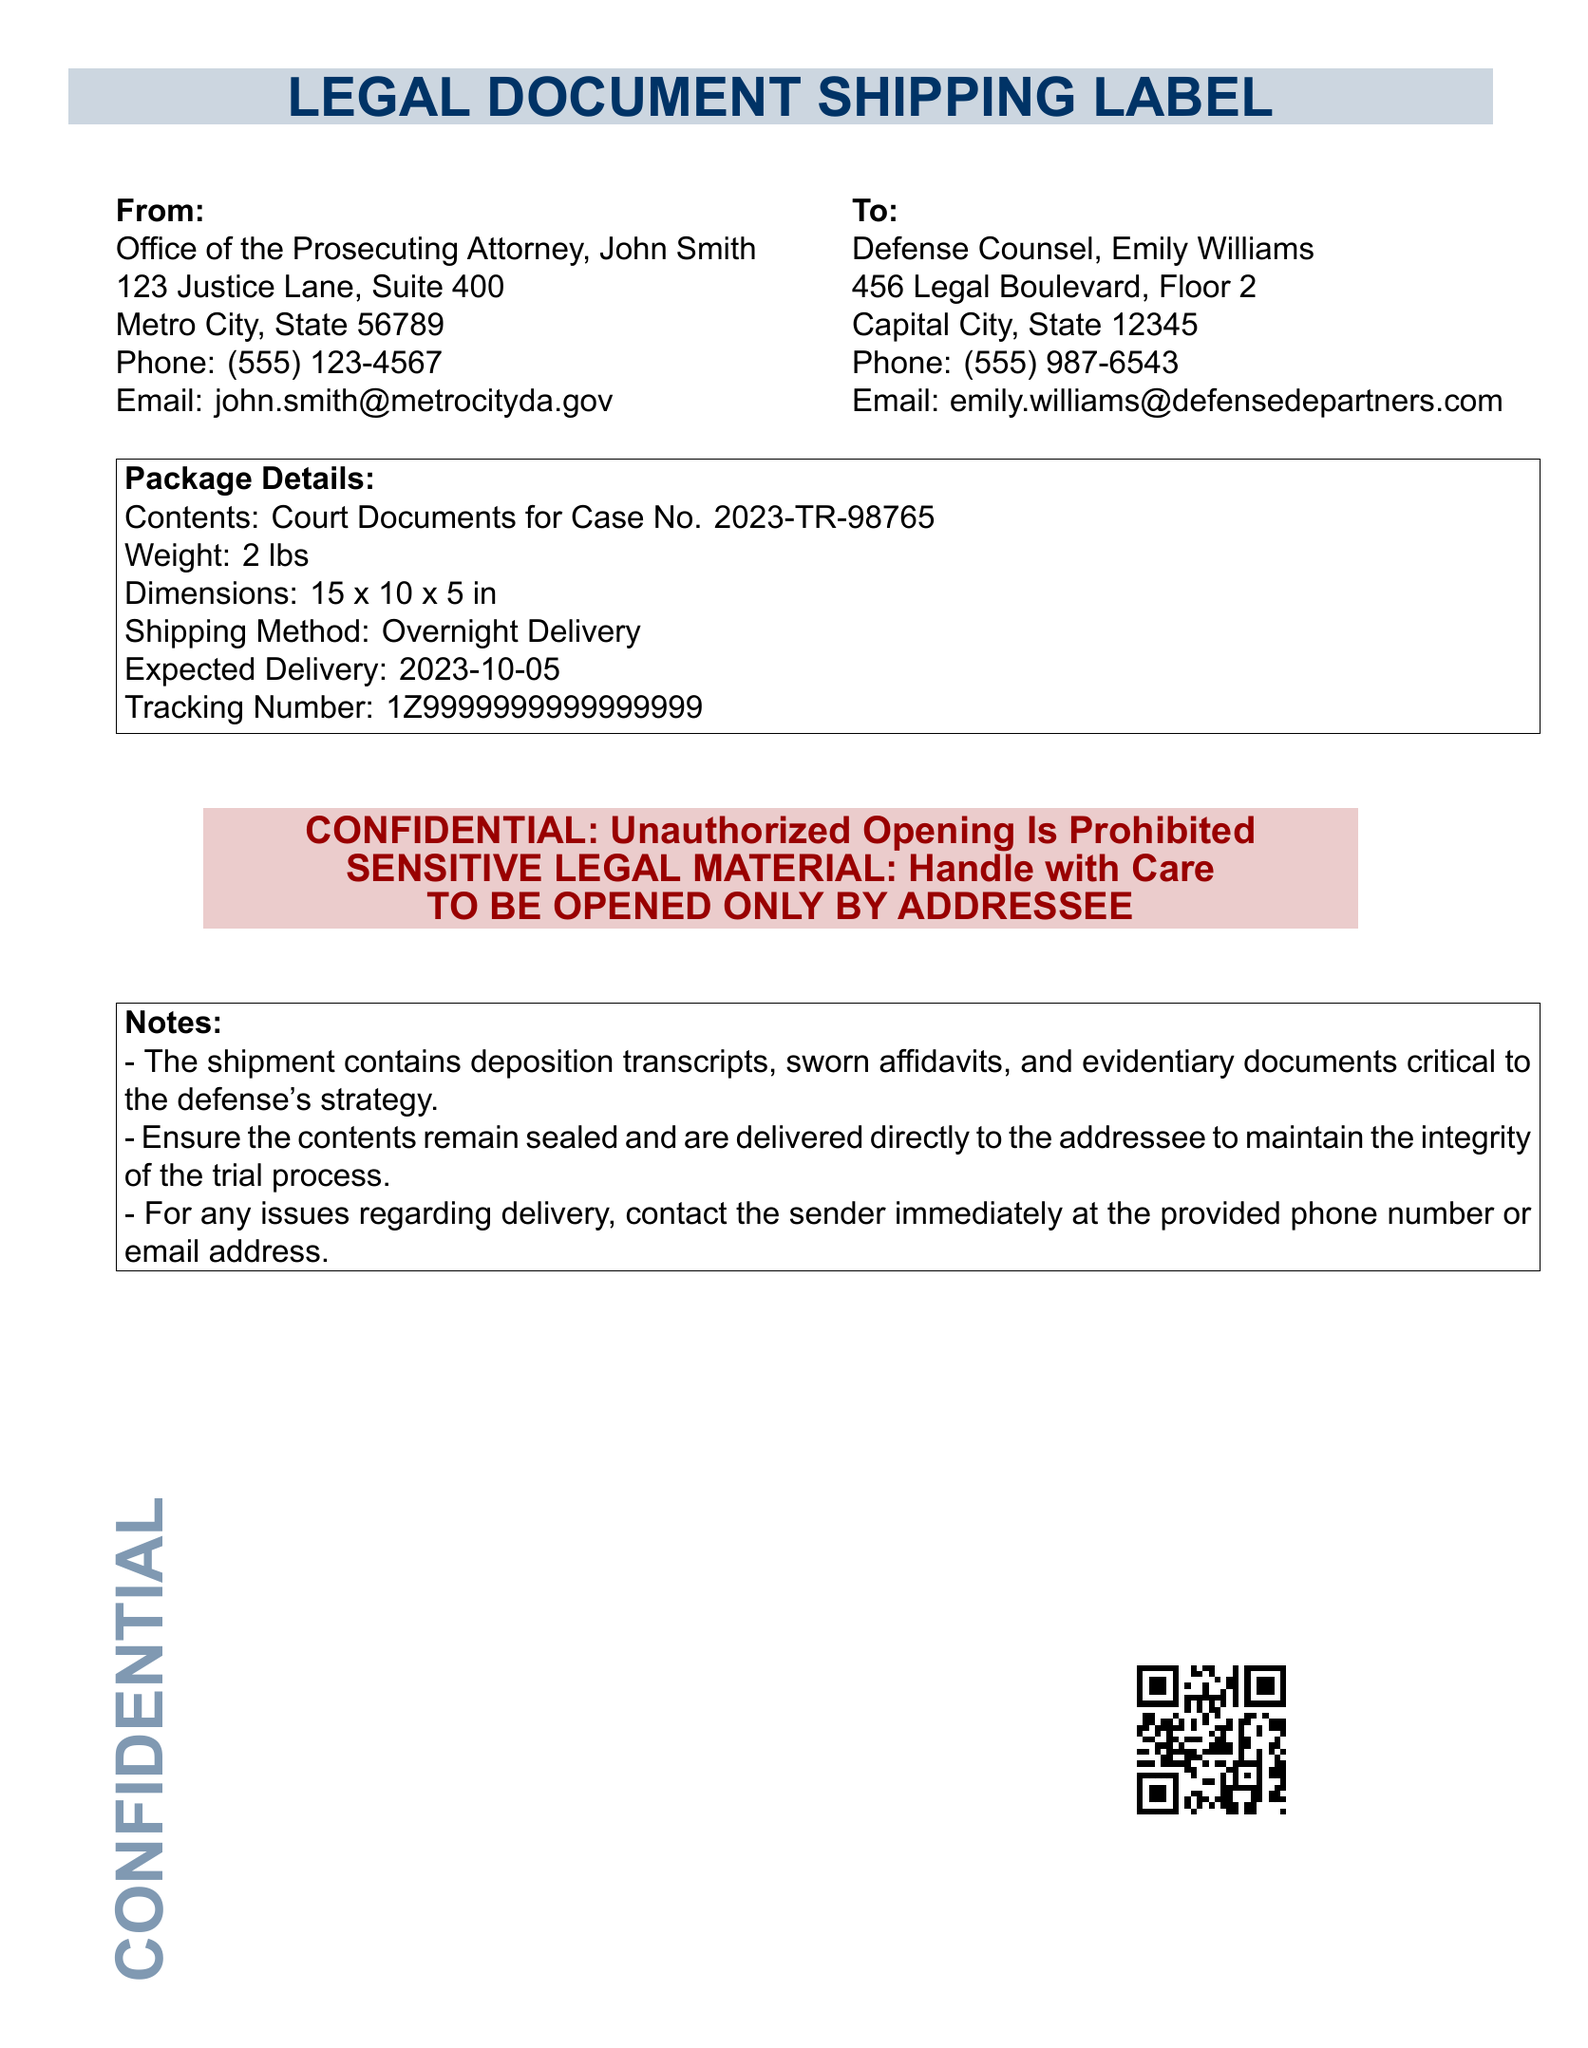What is the sender's name? The sender's name is located in the "From" section of the document, which states: "John Smith".
Answer: John Smith What is the expected delivery date? The expected delivery date is listed under "Package Details," which specifies: "2023-10-05".
Answer: 2023-10-05 What is the weight of the package? The weight of the package is detailed in the "Package Details" section as "2 lbs".
Answer: 2 lbs What is the tracking number for the shipment? The tracking number is found in the "Package Details" section, where it is described as "1Z9999999999999999".
Answer: 1Z9999999999999999 Who is the recipient's email address? The recipient's email address can be found in the "To" section of the document: "emily.williams@defensedepartners.com".
Answer: emily.williams@defensedepartners.com Why is the shipment labeled as confidential? The document specifies that it includes "SENSITIVE LEGAL MATERIAL" and states its confidentiality at the bottom.
Answer: SENSITIVE LEGAL MATERIAL What type of documents are included in the shipment? The notes section describes the contents as "deposition transcripts, sworn affidavits, and evidentiary documents".
Answer: deposition transcripts, sworn affidavits, and evidentiary documents What should be done if there are issues with delivery? The instructions mention "contact the sender immediately at the provided phone number or email address".
Answer: contact the sender immediately What is the shipping method used? The shipping method is specifically stated in the "Package Details" as "Overnight Delivery".
Answer: Overnight Delivery What does the confidentiality stamp instruct? The confidentiality stamp instructs that "[Unauthorized Opening Is Prohibited]".
Answer: Unauthorized Opening Is Prohibited 